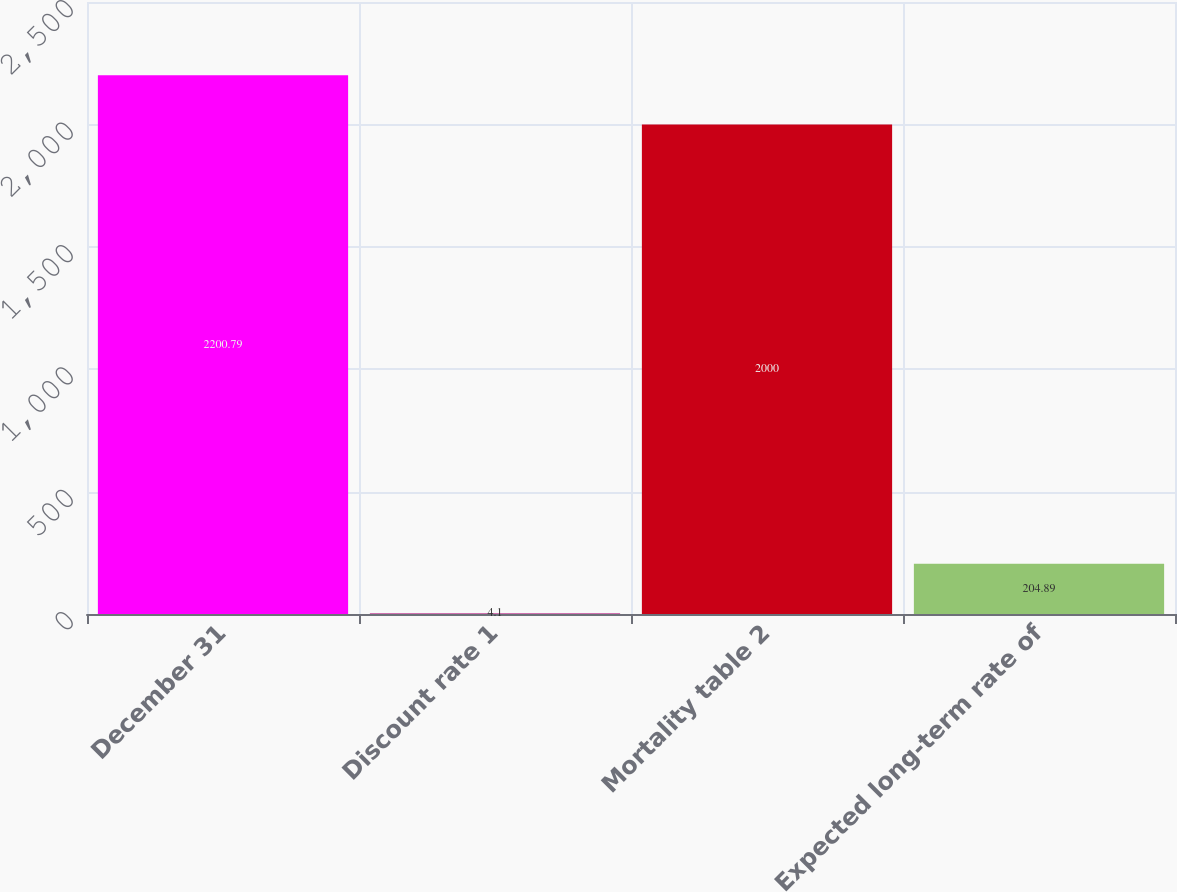Convert chart to OTSL. <chart><loc_0><loc_0><loc_500><loc_500><bar_chart><fcel>December 31<fcel>Discount rate 1<fcel>Mortality table 2<fcel>Expected long-term rate of<nl><fcel>2200.79<fcel>4.1<fcel>2000<fcel>204.89<nl></chart> 